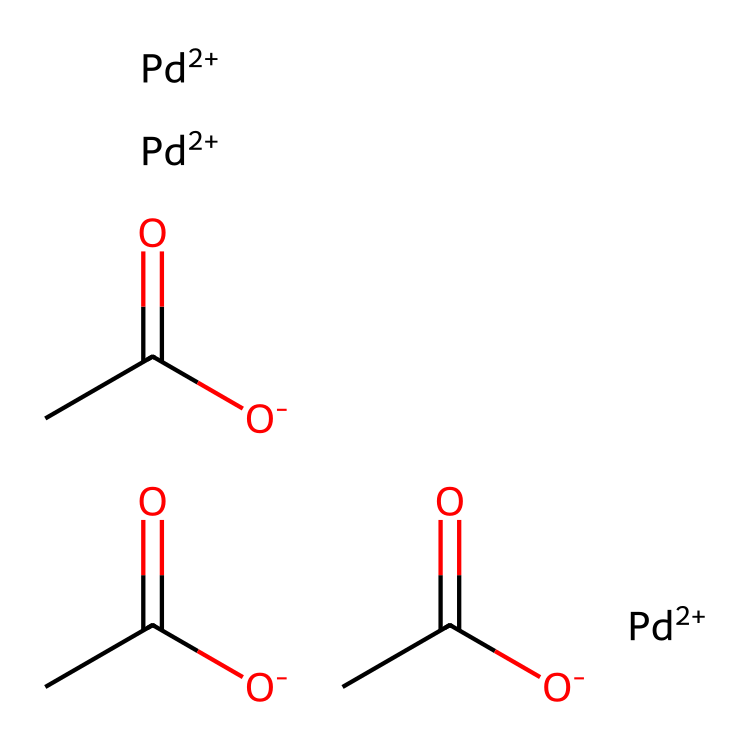What is the molecular formula of palladium(II) acetate? The SMILES representation indicates three acetate groups and one palladium center. Each acetate group has the formula C2H3O2, and since there are three acetate groups attached to one palladium atom, the total molecular formula becomes C6H6O6Pd.
Answer: C6H6O6Pd How many atoms of carbon are present in palladium(II) acetate? From the SMILES structure, there are three acetate groups (each containing two carbon atoms), resulting in a total of six carbon atoms.
Answer: 6 What type of bonding is primarily present in palladium(II) acetate? The compound features coordination bonds between the palladium atom and the acetate ligands. The palladium atom is coordinated to the oxygen of the acetate groups, which is a hallmark of organometallic compounds.
Answer: coordination bonds What is the oxidation state of palladium in this compound? In palladium(II) acetate, the palladium is indicated by the +2 charge in the SMILES, which denotes its oxidation state.
Answer: +2 How many acetate ligands are coordinated to the palladium atom? The SMILES shows three acetate groups attached to the palladium atom, indicating that there are three ligands coordinated to it.
Answer: 3 What type of compound is palladium(II) acetate classified as? Due to its structure, which contains a metal-carbon bond (the palladium atom coordinated with acetate groups), palladium(II) acetate is classified as an organometallic compound.
Answer: organometallic 